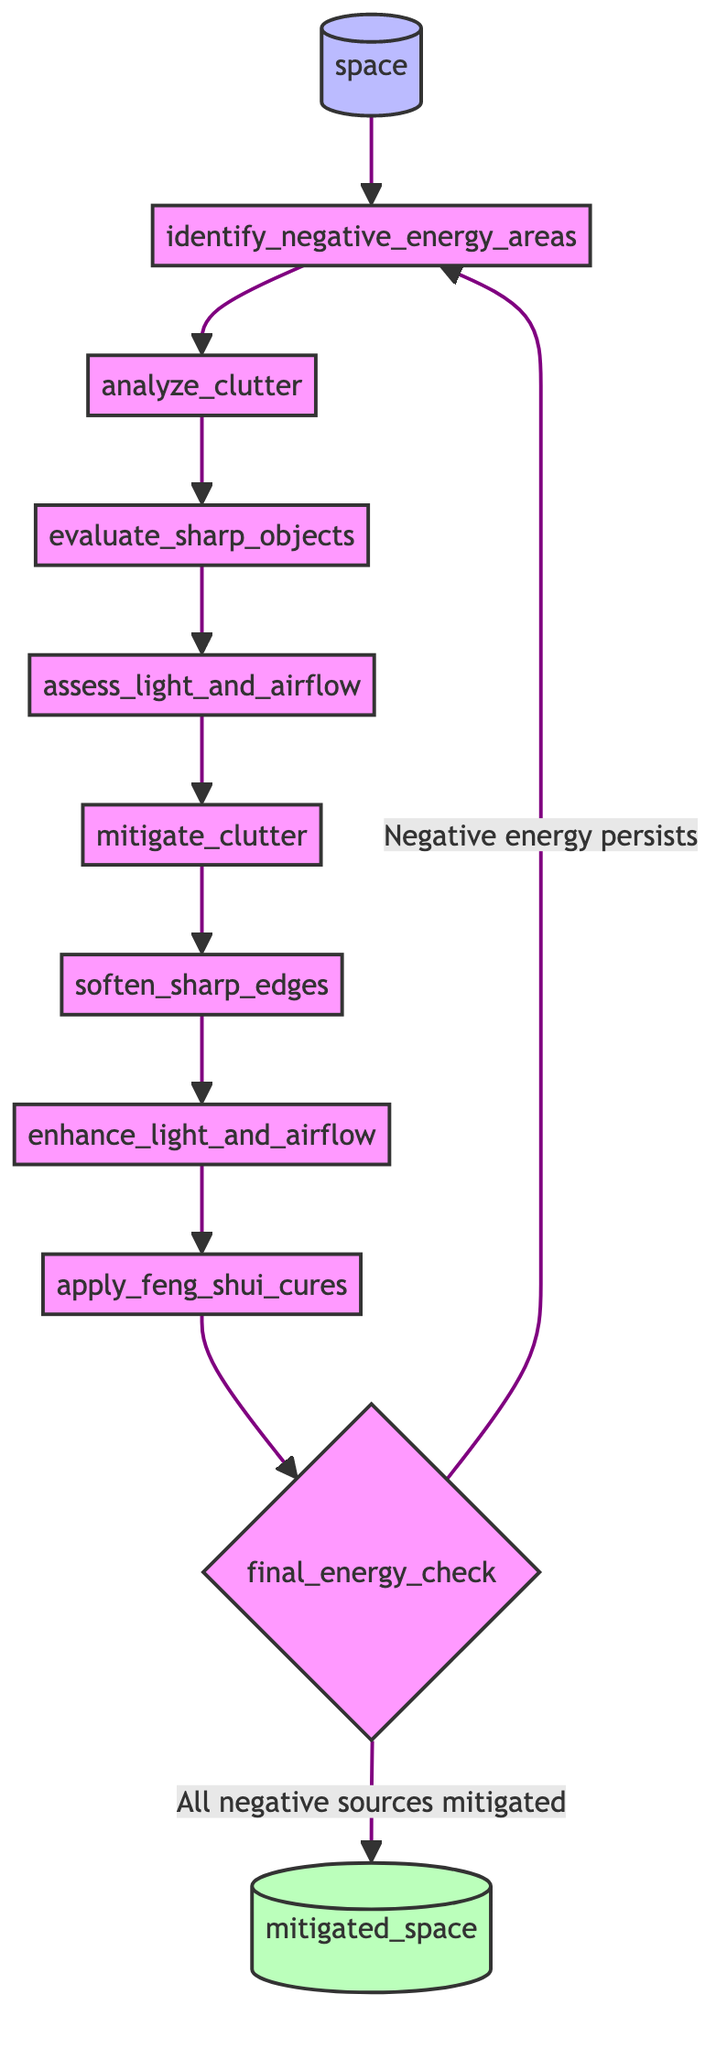What is the initial input for this flowchart? The flowchart starts with the input node labeled "space," indicating that the function requires a specific space to analyze.
Answer: space How many main steps are there to identify and mitigate negative energy sources? By counting the distinct steps from "identify_negative_energy_areas" to "final_energy_check," there are a total of eight main steps before the final check.
Answer: eight What does the step "assess_light_and_airflow" focus on? This step examines the natural light and airflow in the space to ensure that it is balanced and flowing properly rather than being stagnant.
Answer: natural light and airflow What should be done if negative energy persists after the final energy check? If negative energy is still present after the final energy check, the flowchart indicates returning to the "identify_negative_energy_areas" step to re-evaluate the situation.
Answer: return to identify_negative_energy_areas Which step involves removing clutter? The "mitigate_clutter" step explicitly addresses the removal of clutter in the space to improve energy flow.
Answer: mitigate_clutter Is "soften_sharp_edges" generally intended to improve or obstruct energy flow? The step is meant to improve energy flow by using plants or rounded objects to mitigate the harsh effects of sharp edges on the energy in the space.
Answer: improve energy flow What is the purpose of the step "apply_feng_shui_cures"? This step implements various Feng Shui cures such as crystals or wind chimes as remedies for ongoing negative energy issues within the space.
Answer: remedies for persistent negative energy What happens at the end of the flowchart? At the end of the flowchart, if all negative sources are mitigated, the output node provides a "mitigated_space," indicating a successful transformation of the space.
Answer: mitigated_space 